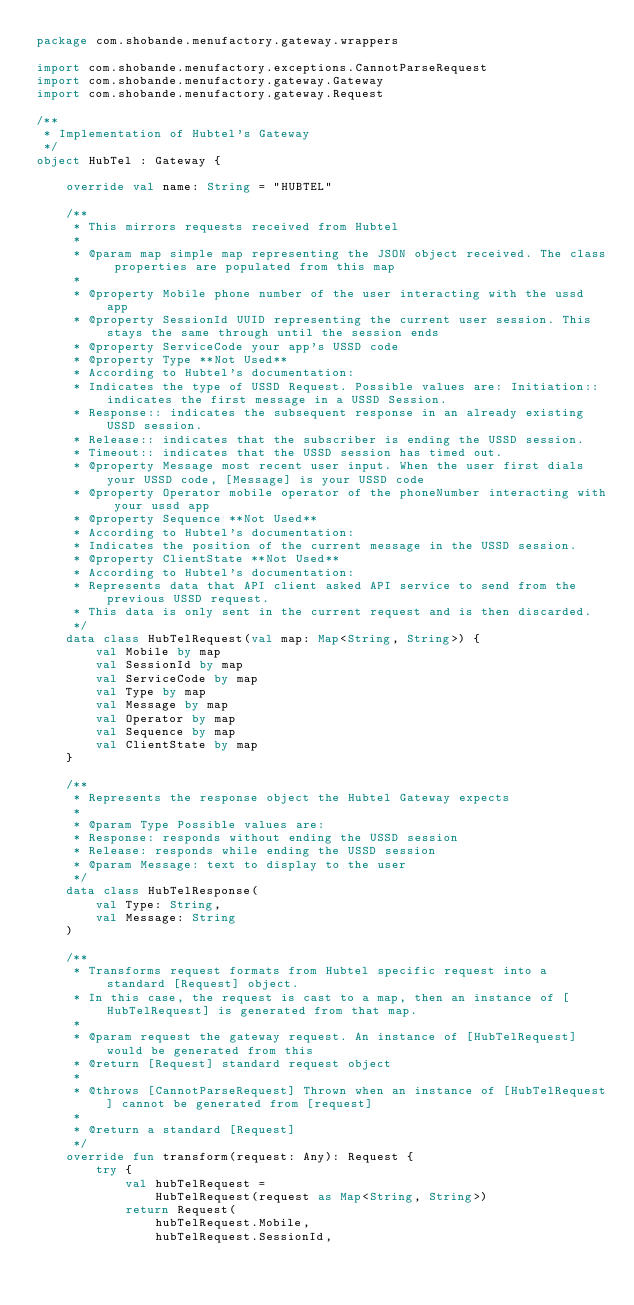Convert code to text. <code><loc_0><loc_0><loc_500><loc_500><_Kotlin_>package com.shobande.menufactory.gateway.wrappers

import com.shobande.menufactory.exceptions.CannotParseRequest
import com.shobande.menufactory.gateway.Gateway
import com.shobande.menufactory.gateway.Request

/**
 * Implementation of Hubtel's Gateway
 */
object HubTel : Gateway {

    override val name: String = "HUBTEL"

    /**
     * This mirrors requests received from Hubtel
     *
     * @param map simple map representing the JSON object received. The class properties are populated from this map
     *
     * @property Mobile phone number of the user interacting with the ussd app
     * @property SessionId UUID representing the current user session. This stays the same through until the session ends
     * @property ServiceCode your app's USSD code
     * @property Type **Not Used**
     * According to Hubtel's documentation:
     * Indicates the type of USSD Request. Possible values are: Initiation:: indicates the first message in a USSD Session.
     * Response:: indicates the subsequent response in an already existing USSD session.
     * Release:: indicates that the subscriber is ending the USSD session.
     * Timeout:: indicates that the USSD session has timed out.
     * @property Message most recent user input. When the user first dials your USSD code, [Message] is your USSD code
     * @property Operator mobile operator of the phoneNumber interacting with your ussd app
     * @property Sequence **Not Used**
     * According to Hubtel's documentation:
     * Indicates the position of the current message in the USSD session.
     * @property ClientState **Not Used**
     * According to Hubtel's documentation:
     * Represents data that API client asked API service to send from the previous USSD request.
     * This data is only sent in the current request and is then discarded.
     */
    data class HubTelRequest(val map: Map<String, String>) {
        val Mobile by map
        val SessionId by map
        val ServiceCode by map
        val Type by map
        val Message by map
        val Operator by map
        val Sequence by map
        val ClientState by map
    }

    /**
     * Represents the response object the Hubtel Gateway expects
     *
     * @param Type Possible values are:
     * Response: responds without ending the USSD session
     * Release: responds while ending the USSD session
     * @param Message: text to display to the user
     */
    data class HubTelResponse(
        val Type: String,
        val Message: String
    )

    /**
     * Transforms request formats from Hubtel specific request into a standard [Request] object.
     * In this case, the request is cast to a map, then an instance of [HubTelRequest] is generated from that map.
     *
     * @param request the gateway request. An instance of [HubTelRequest] would be generated from this
     * @return [Request] standard request object
     *
     * @throws [CannotParseRequest] Thrown when an instance of [HubTelRequest] cannot be generated from [request]
     *
     * @return a standard [Request]
     */
    override fun transform(request: Any): Request {
        try {
            val hubTelRequest =
                HubTelRequest(request as Map<String, String>)
            return Request(
                hubTelRequest.Mobile,
                hubTelRequest.SessionId,</code> 